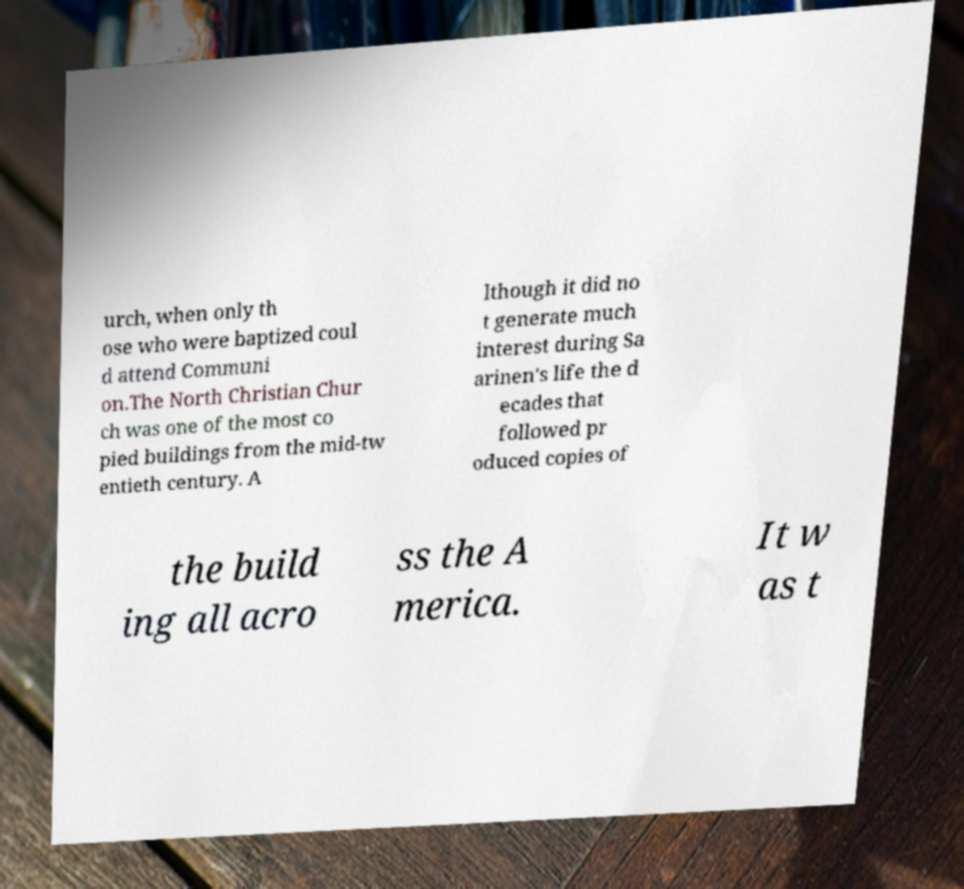Could you assist in decoding the text presented in this image and type it out clearly? urch, when only th ose who were baptized coul d attend Communi on.The North Christian Chur ch was one of the most co pied buildings from the mid-tw entieth century. A lthough it did no t generate much interest during Sa arinen's life the d ecades that followed pr oduced copies of the build ing all acro ss the A merica. It w as t 